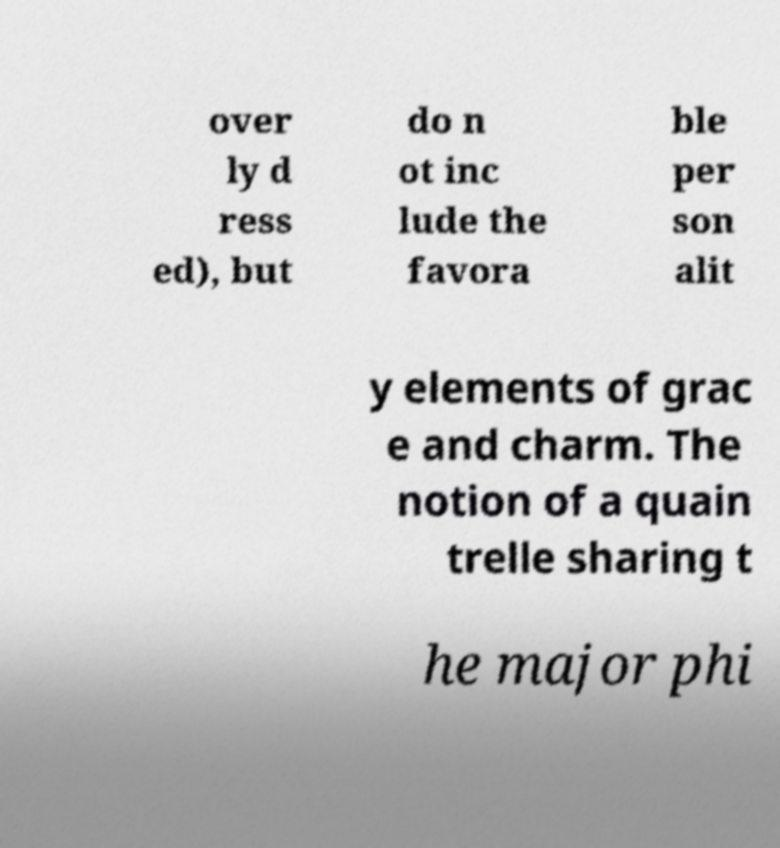Could you extract and type out the text from this image? over ly d ress ed), but do n ot inc lude the favora ble per son alit y elements of grac e and charm. The notion of a quain trelle sharing t he major phi 